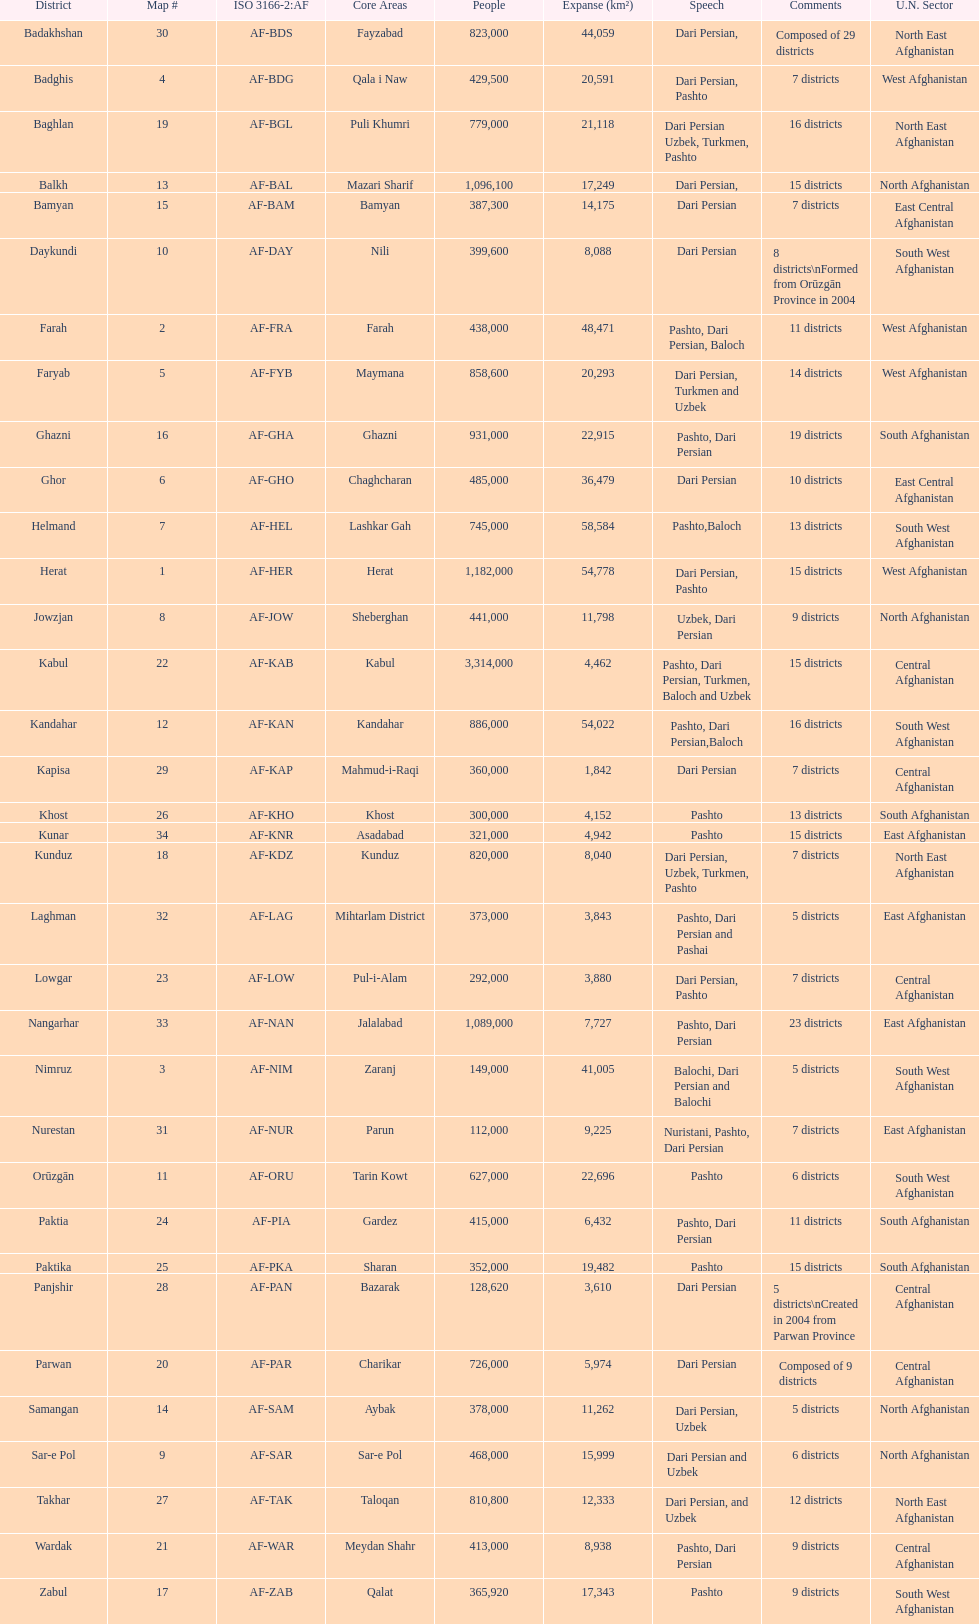What province in afghanistanhas the greatest population? Kabul. 